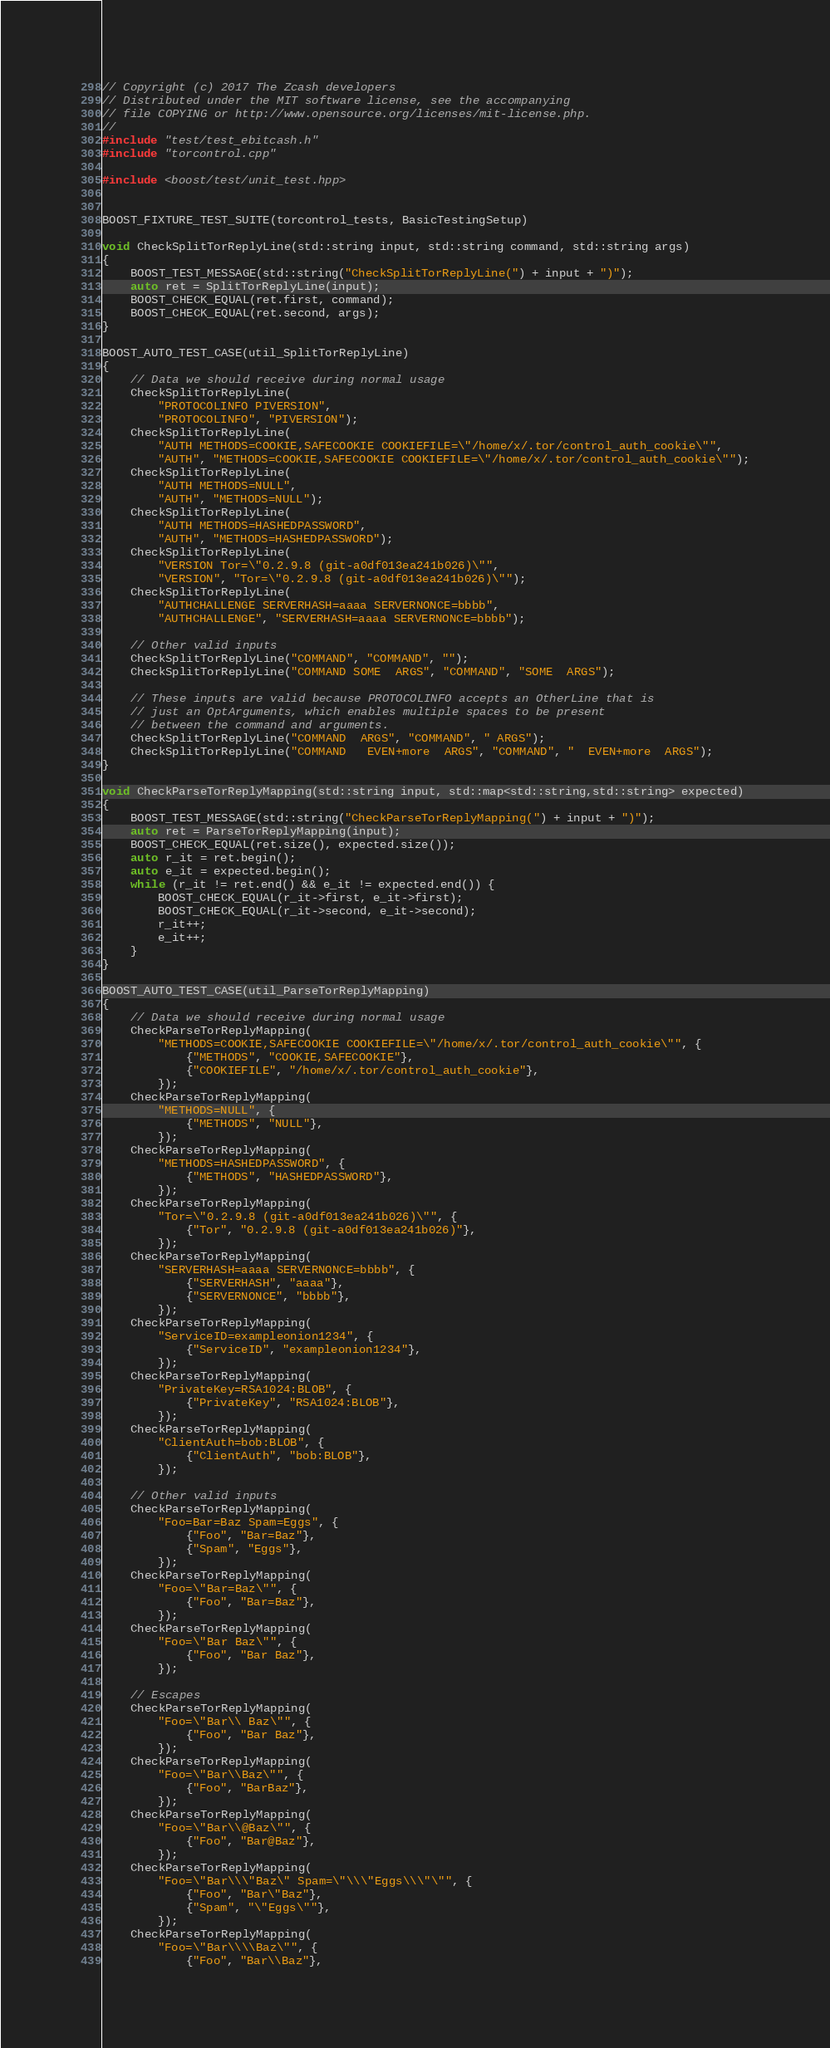Convert code to text. <code><loc_0><loc_0><loc_500><loc_500><_C++_>// Copyright (c) 2017 The Zcash developers
// Distributed under the MIT software license, see the accompanying
// file COPYING or http://www.opensource.org/licenses/mit-license.php.
//
#include "test/test_ebitcash.h"
#include "torcontrol.cpp"

#include <boost/test/unit_test.hpp>


BOOST_FIXTURE_TEST_SUITE(torcontrol_tests, BasicTestingSetup)

void CheckSplitTorReplyLine(std::string input, std::string command, std::string args)
{
    BOOST_TEST_MESSAGE(std::string("CheckSplitTorReplyLine(") + input + ")");
    auto ret = SplitTorReplyLine(input);
    BOOST_CHECK_EQUAL(ret.first, command);
    BOOST_CHECK_EQUAL(ret.second, args);
}

BOOST_AUTO_TEST_CASE(util_SplitTorReplyLine)
{
    // Data we should receive during normal usage
    CheckSplitTorReplyLine(
        "PROTOCOLINFO PIVERSION",
        "PROTOCOLINFO", "PIVERSION");
    CheckSplitTorReplyLine(
        "AUTH METHODS=COOKIE,SAFECOOKIE COOKIEFILE=\"/home/x/.tor/control_auth_cookie\"",
        "AUTH", "METHODS=COOKIE,SAFECOOKIE COOKIEFILE=\"/home/x/.tor/control_auth_cookie\"");
    CheckSplitTorReplyLine(
        "AUTH METHODS=NULL",
        "AUTH", "METHODS=NULL");
    CheckSplitTorReplyLine(
        "AUTH METHODS=HASHEDPASSWORD",
        "AUTH", "METHODS=HASHEDPASSWORD");
    CheckSplitTorReplyLine(
        "VERSION Tor=\"0.2.9.8 (git-a0df013ea241b026)\"",
        "VERSION", "Tor=\"0.2.9.8 (git-a0df013ea241b026)\"");
    CheckSplitTorReplyLine(
        "AUTHCHALLENGE SERVERHASH=aaaa SERVERNONCE=bbbb",
        "AUTHCHALLENGE", "SERVERHASH=aaaa SERVERNONCE=bbbb");

    // Other valid inputs
    CheckSplitTorReplyLine("COMMAND", "COMMAND", "");
    CheckSplitTorReplyLine("COMMAND SOME  ARGS", "COMMAND", "SOME  ARGS");

    // These inputs are valid because PROTOCOLINFO accepts an OtherLine that is
    // just an OptArguments, which enables multiple spaces to be present
    // between the command and arguments.
    CheckSplitTorReplyLine("COMMAND  ARGS", "COMMAND", " ARGS");
    CheckSplitTorReplyLine("COMMAND   EVEN+more  ARGS", "COMMAND", "  EVEN+more  ARGS");
}

void CheckParseTorReplyMapping(std::string input, std::map<std::string,std::string> expected)
{
    BOOST_TEST_MESSAGE(std::string("CheckParseTorReplyMapping(") + input + ")");
    auto ret = ParseTorReplyMapping(input);
    BOOST_CHECK_EQUAL(ret.size(), expected.size());
    auto r_it = ret.begin();
    auto e_it = expected.begin();
    while (r_it != ret.end() && e_it != expected.end()) {
        BOOST_CHECK_EQUAL(r_it->first, e_it->first);
        BOOST_CHECK_EQUAL(r_it->second, e_it->second);
        r_it++;
        e_it++;
    }
}

BOOST_AUTO_TEST_CASE(util_ParseTorReplyMapping)
{
    // Data we should receive during normal usage
    CheckParseTorReplyMapping(
        "METHODS=COOKIE,SAFECOOKIE COOKIEFILE=\"/home/x/.tor/control_auth_cookie\"", {
            {"METHODS", "COOKIE,SAFECOOKIE"},
            {"COOKIEFILE", "/home/x/.tor/control_auth_cookie"},
        });
    CheckParseTorReplyMapping(
        "METHODS=NULL", {
            {"METHODS", "NULL"},
        });
    CheckParseTorReplyMapping(
        "METHODS=HASHEDPASSWORD", {
            {"METHODS", "HASHEDPASSWORD"},
        });
    CheckParseTorReplyMapping(
        "Tor=\"0.2.9.8 (git-a0df013ea241b026)\"", {
            {"Tor", "0.2.9.8 (git-a0df013ea241b026)"},
        });
    CheckParseTorReplyMapping(
        "SERVERHASH=aaaa SERVERNONCE=bbbb", {
            {"SERVERHASH", "aaaa"},
            {"SERVERNONCE", "bbbb"},
        });
    CheckParseTorReplyMapping(
        "ServiceID=exampleonion1234", {
            {"ServiceID", "exampleonion1234"},
        });
    CheckParseTorReplyMapping(
        "PrivateKey=RSA1024:BLOB", {
            {"PrivateKey", "RSA1024:BLOB"},
        });
    CheckParseTorReplyMapping(
        "ClientAuth=bob:BLOB", {
            {"ClientAuth", "bob:BLOB"},
        });

    // Other valid inputs
    CheckParseTorReplyMapping(
        "Foo=Bar=Baz Spam=Eggs", {
            {"Foo", "Bar=Baz"},
            {"Spam", "Eggs"},
        });
    CheckParseTorReplyMapping(
        "Foo=\"Bar=Baz\"", {
            {"Foo", "Bar=Baz"},
        });
    CheckParseTorReplyMapping(
        "Foo=\"Bar Baz\"", {
            {"Foo", "Bar Baz"},
        });

    // Escapes
    CheckParseTorReplyMapping(
        "Foo=\"Bar\\ Baz\"", {
            {"Foo", "Bar Baz"},
        });
    CheckParseTorReplyMapping(
        "Foo=\"Bar\\Baz\"", {
            {"Foo", "BarBaz"},
        });
    CheckParseTorReplyMapping(
        "Foo=\"Bar\\@Baz\"", {
            {"Foo", "Bar@Baz"},
        });
    CheckParseTorReplyMapping(
        "Foo=\"Bar\\\"Baz\" Spam=\"\\\"Eggs\\\"\"", {
            {"Foo", "Bar\"Baz"},
            {"Spam", "\"Eggs\""},
        });
    CheckParseTorReplyMapping(
        "Foo=\"Bar\\\\Baz\"", {
            {"Foo", "Bar\\Baz"},</code> 